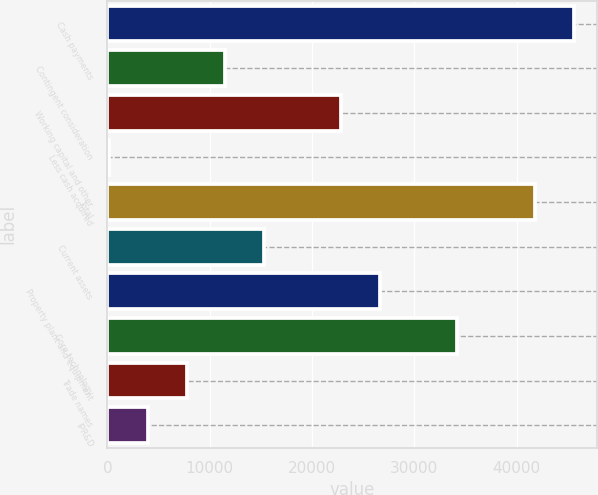Convert chart to OTSL. <chart><loc_0><loc_0><loc_500><loc_500><bar_chart><fcel>Cash payments<fcel>Contingent consideration<fcel>Working capital and other<fcel>Less cash acquired<fcel>Total<fcel>Current assets<fcel>Property plant and equipment<fcel>Core technology<fcel>Trade names<fcel>IPR&D<nl><fcel>45565<fcel>11522.5<fcel>22870<fcel>175<fcel>41782.5<fcel>15305<fcel>26652.5<fcel>34217.5<fcel>7740<fcel>3957.5<nl></chart> 